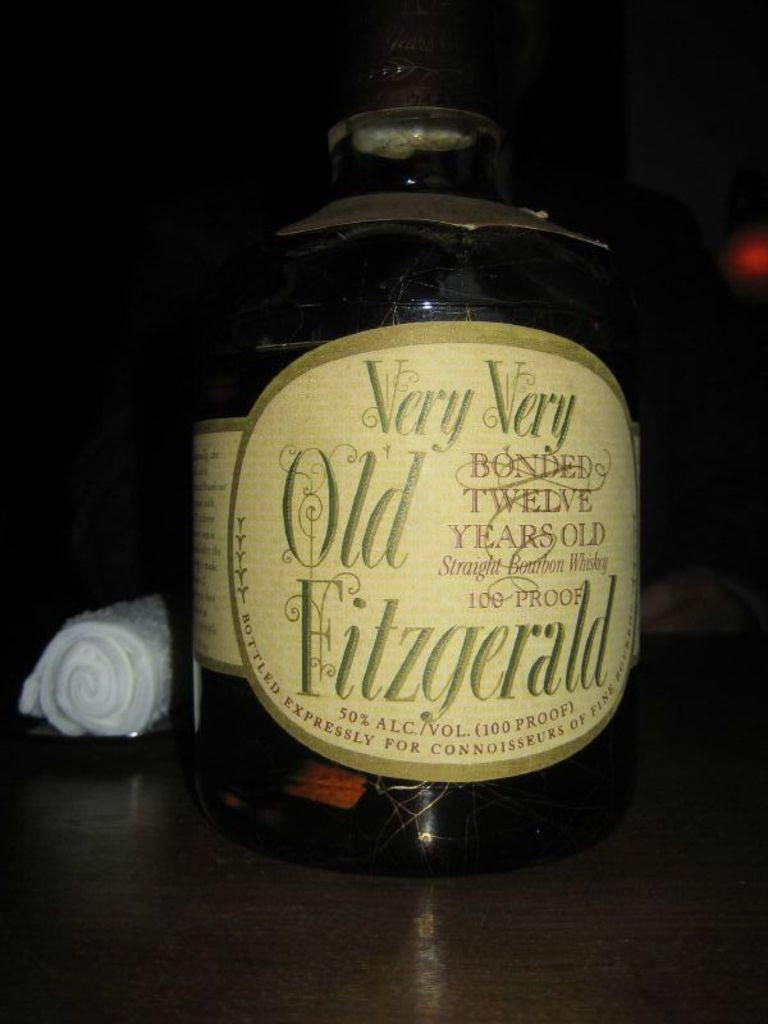<image>
Describe the image concisely. A bottle of twelve year old Fizgerald 100 proof bourban whiskey with a tan label. 